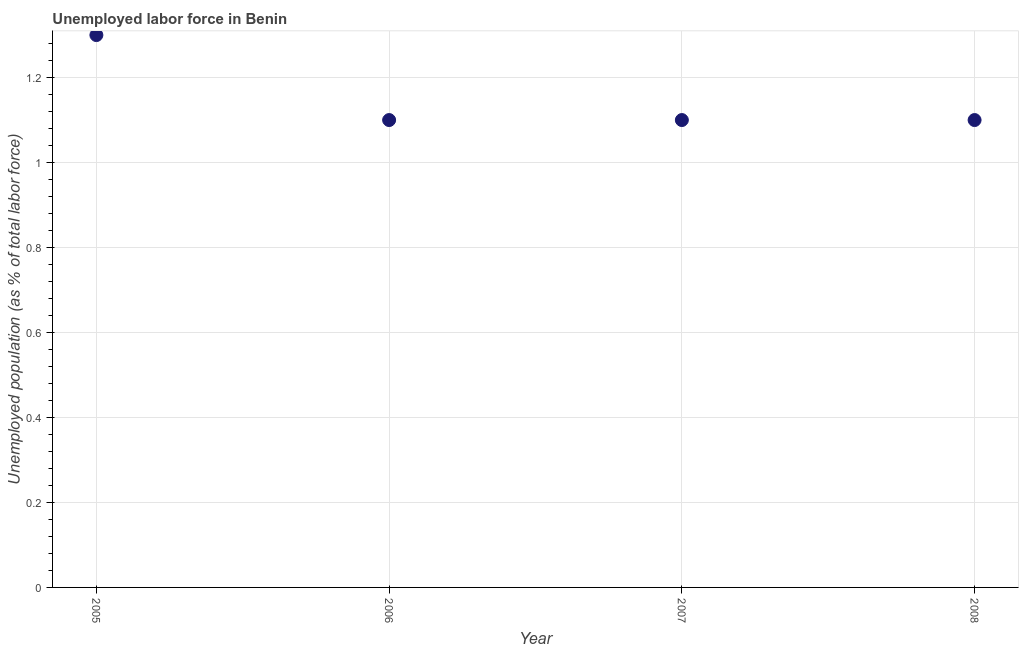What is the total unemployed population in 2007?
Give a very brief answer. 1.1. Across all years, what is the maximum total unemployed population?
Offer a terse response. 1.3. Across all years, what is the minimum total unemployed population?
Give a very brief answer. 1.1. In which year was the total unemployed population minimum?
Your answer should be compact. 2006. What is the sum of the total unemployed population?
Ensure brevity in your answer.  4.6. What is the difference between the total unemployed population in 2005 and 2008?
Offer a terse response. 0.2. What is the average total unemployed population per year?
Give a very brief answer. 1.15. What is the median total unemployed population?
Ensure brevity in your answer.  1.1. In how many years, is the total unemployed population greater than 0.28 %?
Your response must be concise. 4. Do a majority of the years between 2005 and 2008 (inclusive) have total unemployed population greater than 0.7600000000000001 %?
Ensure brevity in your answer.  Yes. What is the ratio of the total unemployed population in 2006 to that in 2007?
Your answer should be very brief. 1. Is the total unemployed population in 2006 less than that in 2007?
Give a very brief answer. No. Is the difference between the total unemployed population in 2005 and 2008 greater than the difference between any two years?
Make the answer very short. Yes. What is the difference between the highest and the second highest total unemployed population?
Offer a terse response. 0.2. Is the sum of the total unemployed population in 2005 and 2007 greater than the maximum total unemployed population across all years?
Offer a terse response. Yes. What is the difference between the highest and the lowest total unemployed population?
Your response must be concise. 0.2. In how many years, is the total unemployed population greater than the average total unemployed population taken over all years?
Keep it short and to the point. 1. How many dotlines are there?
Provide a succinct answer. 1. How many years are there in the graph?
Provide a short and direct response. 4. What is the difference between two consecutive major ticks on the Y-axis?
Ensure brevity in your answer.  0.2. Are the values on the major ticks of Y-axis written in scientific E-notation?
Your answer should be very brief. No. Does the graph contain grids?
Keep it short and to the point. Yes. What is the title of the graph?
Offer a very short reply. Unemployed labor force in Benin. What is the label or title of the Y-axis?
Make the answer very short. Unemployed population (as % of total labor force). What is the Unemployed population (as % of total labor force) in 2005?
Give a very brief answer. 1.3. What is the Unemployed population (as % of total labor force) in 2006?
Offer a terse response. 1.1. What is the Unemployed population (as % of total labor force) in 2007?
Make the answer very short. 1.1. What is the Unemployed population (as % of total labor force) in 2008?
Give a very brief answer. 1.1. What is the difference between the Unemployed population (as % of total labor force) in 2005 and 2007?
Your answer should be compact. 0.2. What is the difference between the Unemployed population (as % of total labor force) in 2005 and 2008?
Your answer should be compact. 0.2. What is the difference between the Unemployed population (as % of total labor force) in 2006 and 2008?
Provide a short and direct response. 0. What is the ratio of the Unemployed population (as % of total labor force) in 2005 to that in 2006?
Your answer should be very brief. 1.18. What is the ratio of the Unemployed population (as % of total labor force) in 2005 to that in 2007?
Your answer should be very brief. 1.18. What is the ratio of the Unemployed population (as % of total labor force) in 2005 to that in 2008?
Provide a succinct answer. 1.18. 